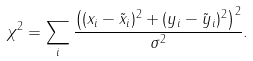Convert formula to latex. <formula><loc_0><loc_0><loc_500><loc_500>\chi ^ { 2 } = \sum _ { i } \frac { \left ( ( x _ { i } - \tilde { x } _ { i } ) ^ { 2 } + ( y _ { i } - \tilde { y } _ { i } ) ^ { 2 } \right ) ^ { 2 } } { \sigma ^ { 2 } } .</formula> 